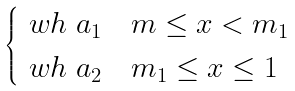<formula> <loc_0><loc_0><loc_500><loc_500>\begin{cases} \ w h \ a _ { 1 } & m \leq x < m _ { 1 } \\ \ w h \ a _ { 2 } & m _ { 1 } \leq x \leq 1 \end{cases}</formula> 